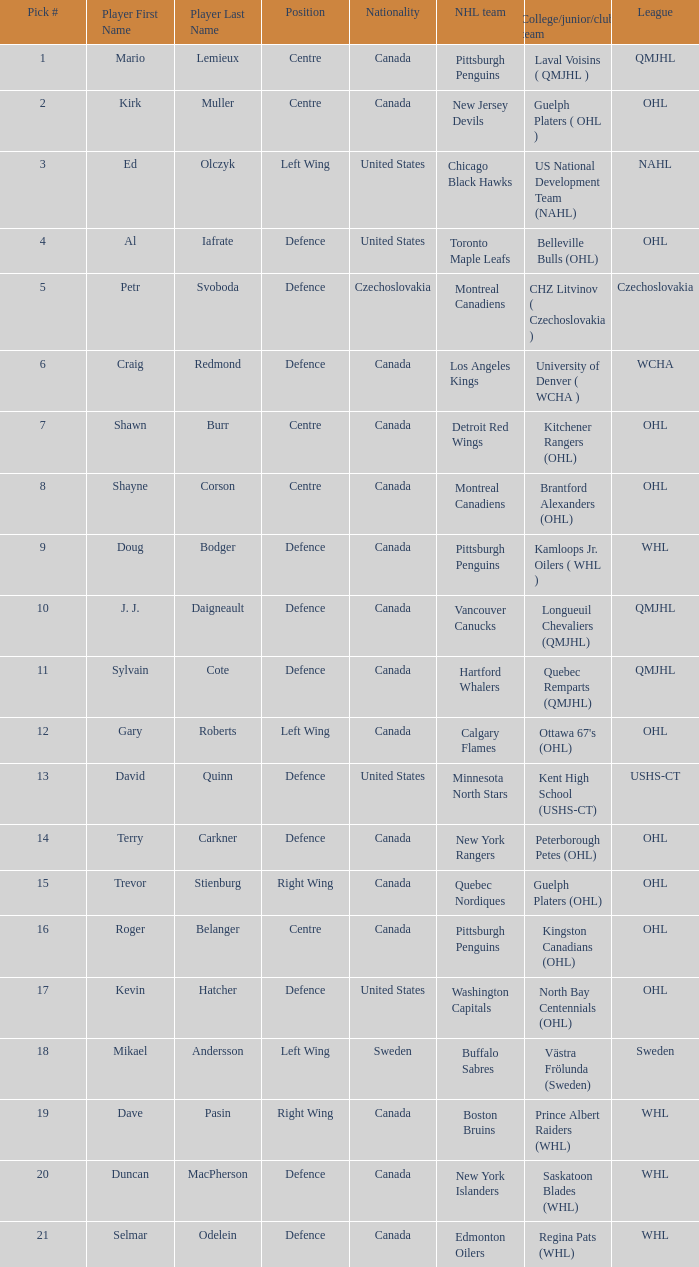What player is draft pick 17? Kevin Hatcher. Would you be able to parse every entry in this table? {'header': ['Pick #', 'Player First Name', 'Player Last Name', 'Position', 'Nationality', 'NHL team', 'College/junior/club team', 'League'], 'rows': [['1', 'Mario', 'Lemieux', 'Centre', 'Canada', 'Pittsburgh Penguins', 'Laval Voisins ( QMJHL )', 'QMJHL'], ['2', 'Kirk', 'Muller', 'Centre', 'Canada', 'New Jersey Devils', 'Guelph Platers ( OHL )', 'OHL'], ['3', 'Ed', 'Olczyk', 'Left Wing', 'United States', 'Chicago Black Hawks', 'US National Development Team (NAHL)', 'NAHL'], ['4', 'Al', 'Iafrate', 'Defence', 'United States', 'Toronto Maple Leafs', 'Belleville Bulls (OHL)', 'OHL'], ['5', 'Petr', 'Svoboda', 'Defence', 'Czechoslovakia', 'Montreal Canadiens', 'CHZ Litvinov ( Czechoslovakia )', 'Czechoslovakia'], ['6', 'Craig', 'Redmond', 'Defence', 'Canada', 'Los Angeles Kings', 'University of Denver ( WCHA )', 'WCHA'], ['7', 'Shawn', 'Burr', 'Centre', 'Canada', 'Detroit Red Wings', 'Kitchener Rangers (OHL)', 'OHL'], ['8', 'Shayne', 'Corson', 'Centre', 'Canada', 'Montreal Canadiens', 'Brantford Alexanders (OHL)', 'OHL'], ['9', 'Doug', 'Bodger', 'Defence', 'Canada', 'Pittsburgh Penguins', 'Kamloops Jr. Oilers ( WHL )', 'WHL'], ['10', 'J. J.', 'Daigneault', 'Defence', 'Canada', 'Vancouver Canucks', 'Longueuil Chevaliers (QMJHL)', 'QMJHL'], ['11', 'Sylvain', 'Cote', 'Defence', 'Canada', 'Hartford Whalers', 'Quebec Remparts (QMJHL)', 'QMJHL'], ['12', 'Gary', 'Roberts', 'Left Wing', 'Canada', 'Calgary Flames', "Ottawa 67's (OHL)", 'OHL'], ['13', 'David', 'Quinn', 'Defence', 'United States', 'Minnesota North Stars', 'Kent High School (USHS-CT)', 'USHS-CT'], ['14', 'Terry', 'Carkner', 'Defence', 'Canada', 'New York Rangers', 'Peterborough Petes (OHL)', 'OHL'], ['15', 'Trevor', 'Stienburg', 'Right Wing', 'Canada', 'Quebec Nordiques', 'Guelph Platers (OHL)', 'OHL'], ['16', 'Roger', 'Belanger', 'Centre', 'Canada', 'Pittsburgh Penguins', 'Kingston Canadians (OHL)', 'OHL'], ['17', 'Kevin', 'Hatcher', 'Defence', 'United States', 'Washington Capitals', 'North Bay Centennials (OHL)', 'OHL'], ['18', 'Mikael', 'Andersson', 'Left Wing', 'Sweden', 'Buffalo Sabres', 'Västra Frölunda (Sweden)', 'Sweden'], ['19', 'Dave', 'Pasin', 'Right Wing', 'Canada', 'Boston Bruins', 'Prince Albert Raiders (WHL)', 'WHL'], ['20', 'Duncan', 'MacPherson', 'Defence', 'Canada', 'New York Islanders', 'Saskatoon Blades (WHL)', 'WHL'], ['21', 'Selmar', 'Odelein', 'Defence', 'Canada', 'Edmonton Oilers', 'Regina Pats (WHL)', 'WHL']]} 